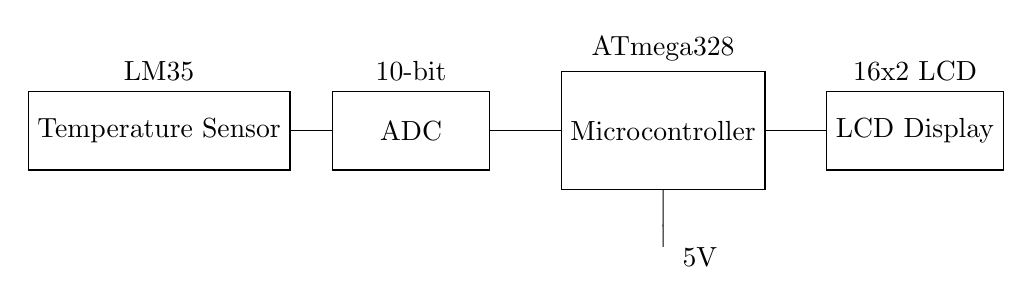What is the temperature sensor used in this circuit? The temperature sensor is labeled as LM35 in the circuit diagram. It is a common temperature sensor known for its analog output.
Answer: LM35 What type of display is connected to the microcontroller? The display is labeled as a 16x2 LCD in the circuit. This type of LCD can display 16 characters per line and has 2 lines.
Answer: 16x2 LCD How many bits does the ADC have? The ADC is labeled as 10-bit in the circuit diagram. This means it can convert an analog signal into a digital signal with 1024 discrete values (2 to the power of 10).
Answer: 10-bit What component receives the temperature data from the sensor? The ADC receives the temperature data from the sensor. The connections in the circuit show that signals flow from the temperature sensor (LM35) to the ADC.
Answer: ADC Which microcontroller is used in this circuit? The microcontroller is labeled as ATmega328. This specific microcontroller is widely used in embedded systems for processing data from sensors.
Answer: ATmega328 What is the power supply voltage for this circuit? The circuit shows a power supply voltage of 5V, which is indicated next to the battery symbol connected to the microcontroller.
Answer: 5V 